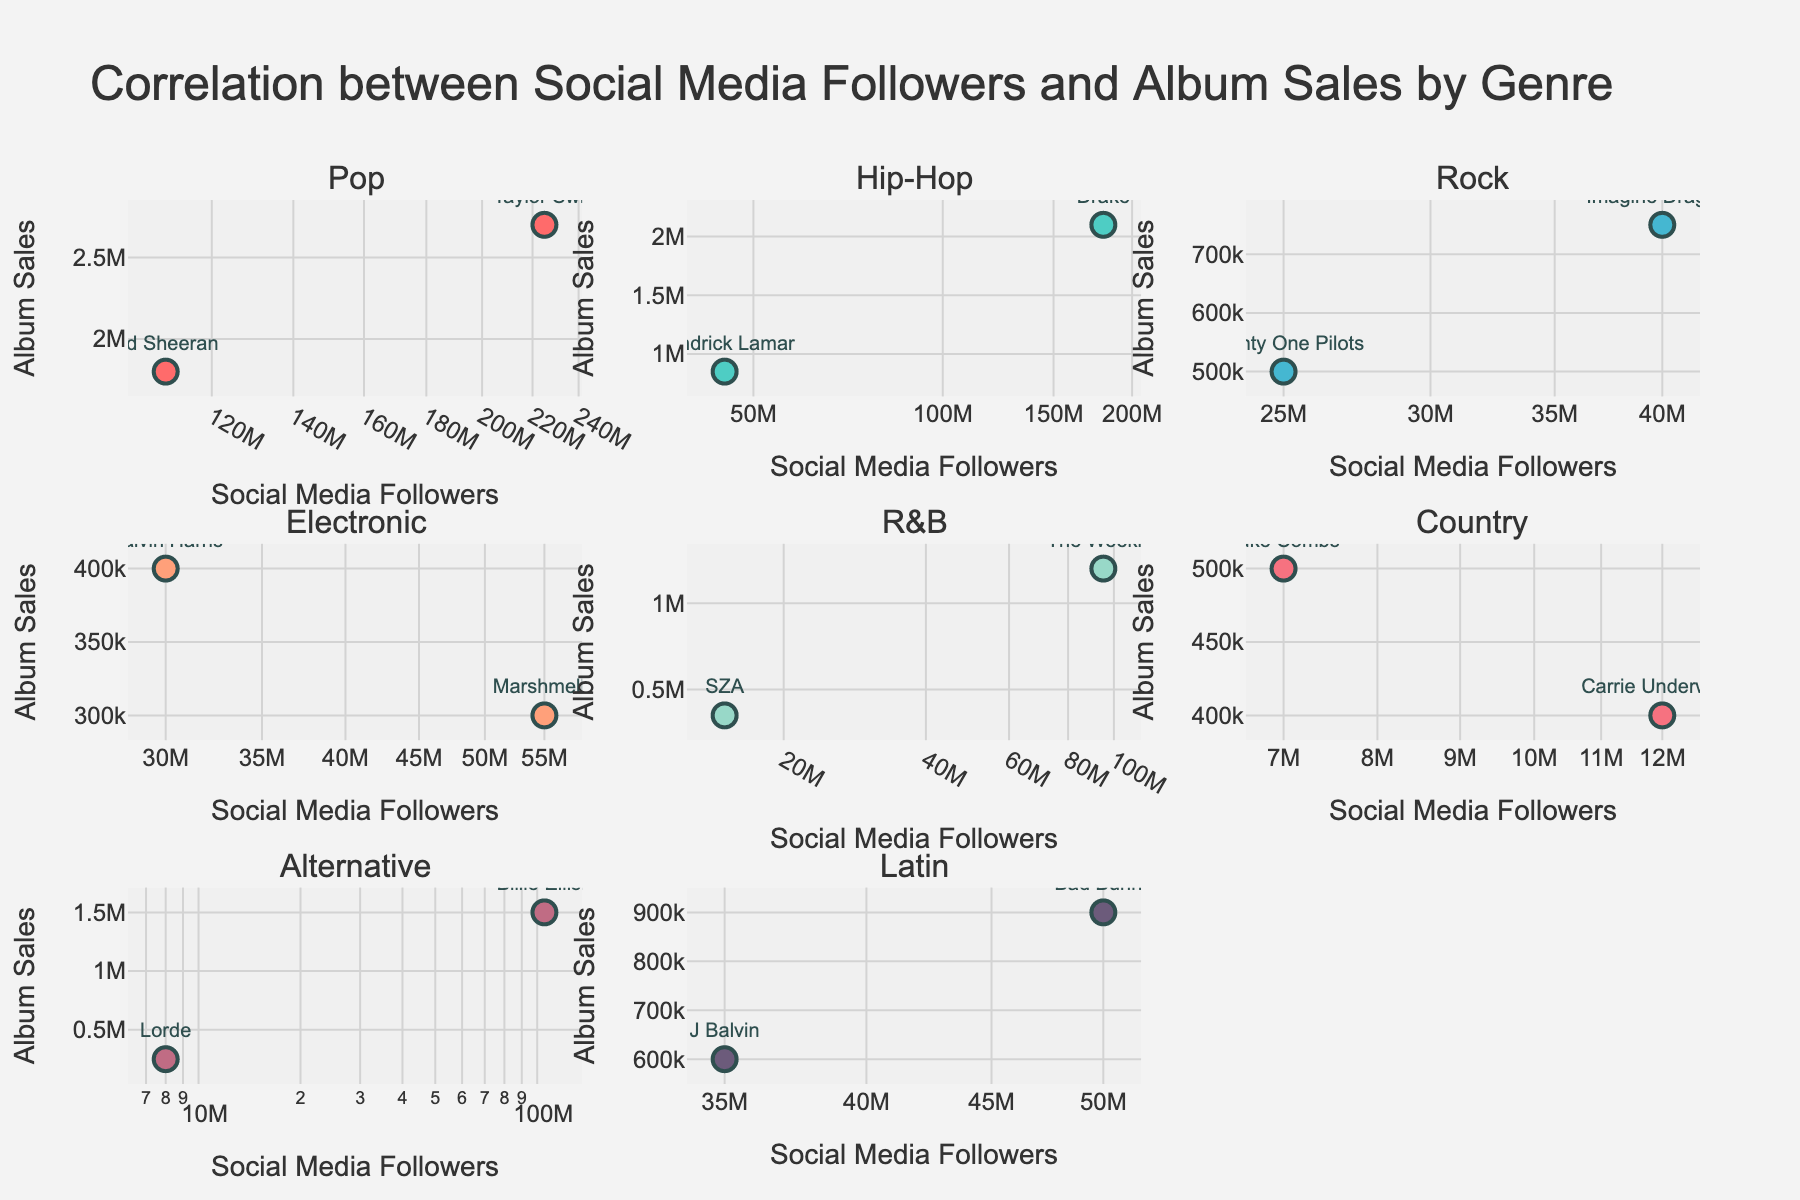How many music genres are shown in the figure? There are subplot titles for each genre. Count the number of unique subplot titles to determine the number of genres.
Answer: 7 What genre has the highest number of social media followers for a single artist, and who is that artist? Look at the genre subplots and identify the artist with the maximum social media followers. In the Pop genre subplot, Taylor Swift has the highest with 225 million followers.
Answer: Pop, Taylor Swift Which genre has the highest album sales for an artist, and who is that artist? Refer to the subplots and identify the artist with the maximum album sales. The Pop genre shows Taylor Swift with the highest album sales of 2.7 million.
Answer: Pop, Taylor Swift Are there any genres where one artist has significantly more social media followers than the other artist within that genre? Compare the social media followers within each genre's subplot. Pop (Taylor Swift vs. Ed Sheeran), and Hip-Hop (Drake vs. Kendrick Lamar) show a significant difference.
Answer: Yes In the R&B genre subplot, what is the difference in album sales between The Weeknd and SZA? Look at The Weeknd's album sales (1.2 million) and SZA's album sales (350,000). The difference is 1.2 million - 350,000 = 850,000.
Answer: 850,000 Which two artists from different genres have the closest number of social media followers? Compare the social media followers across subplots. Ed Sheeran (Pop, 110 million) and Billie Eilish (Alternative, 105 million) are closest.
Answer: Ed Sheeran and Billie Eilish What is the general trend between social media followers and album sales across all subplots? Observe whether higher social media followers generally correspond to higher album sales in each genre's subplot. A positive correlation is observed.
Answer: Positive correlation Which genre has the smallest range in social media followers between its artists? Calculate the range of followers for each genre by subtracting the smallest value from the largest. Rock (Imagine Dragons: 40M, Twenty One Pilots: 25M) has the smallest range of 15 million.
Answer: Rock Comparing Hip-Hop and Rock, which genre has a stronger positive correlation between social media followers and album sales? Evaluate the scatter plot pattern for both genres. Hip-Hop shows a clearer upward trend, indicating a stronger positive correlation than Rock.
Answer: Hip-Hop 